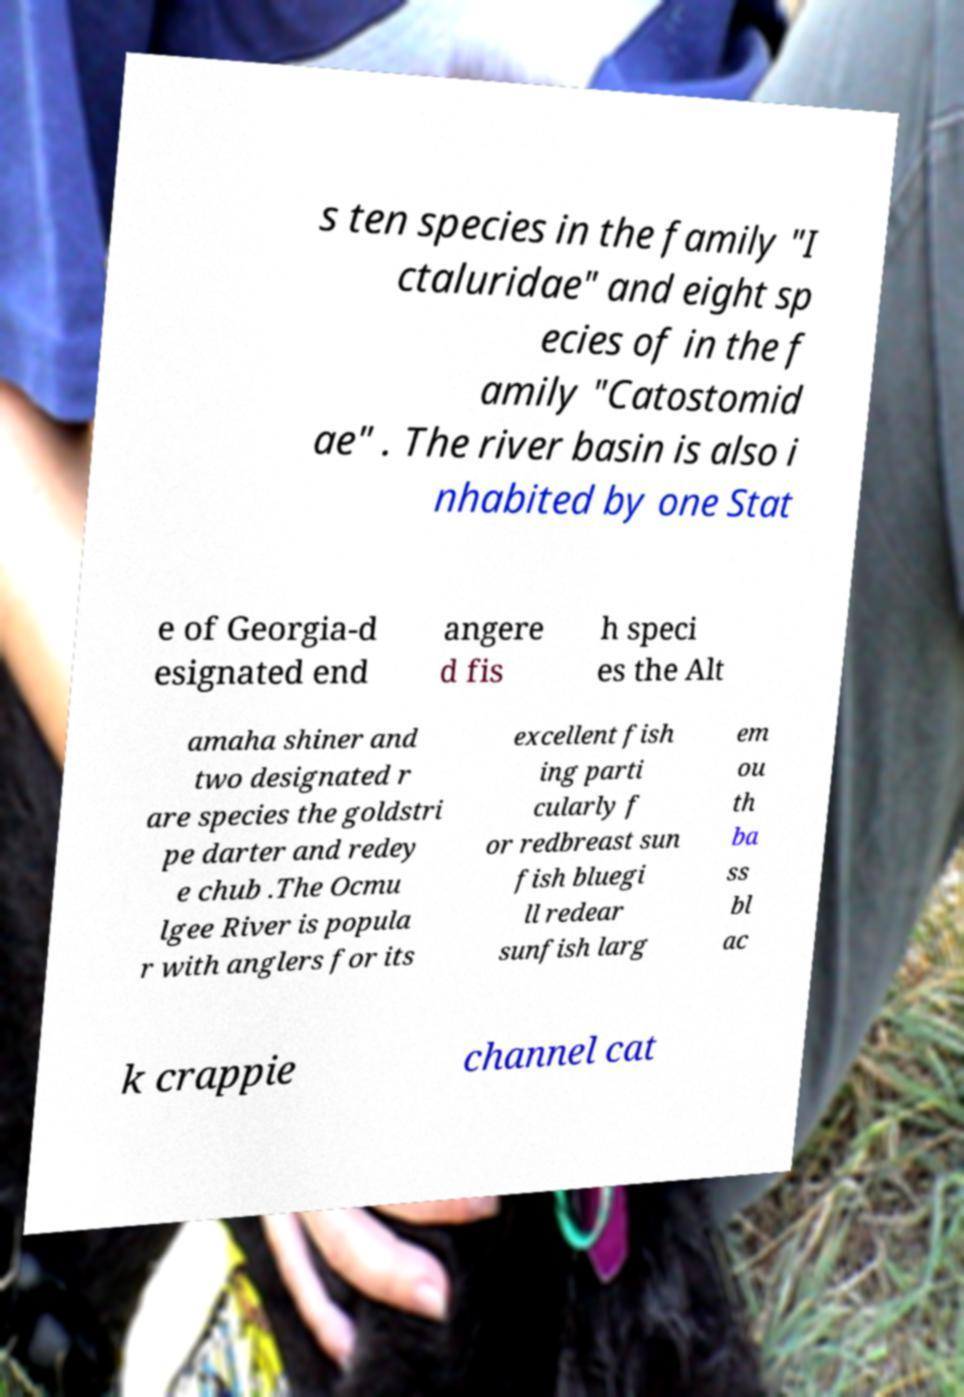Please identify and transcribe the text found in this image. s ten species in the family "I ctaluridae" and eight sp ecies of in the f amily "Catostomid ae" . The river basin is also i nhabited by one Stat e of Georgia-d esignated end angere d fis h speci es the Alt amaha shiner and two designated r are species the goldstri pe darter and redey e chub .The Ocmu lgee River is popula r with anglers for its excellent fish ing parti cularly f or redbreast sun fish bluegi ll redear sunfish larg em ou th ba ss bl ac k crappie channel cat 